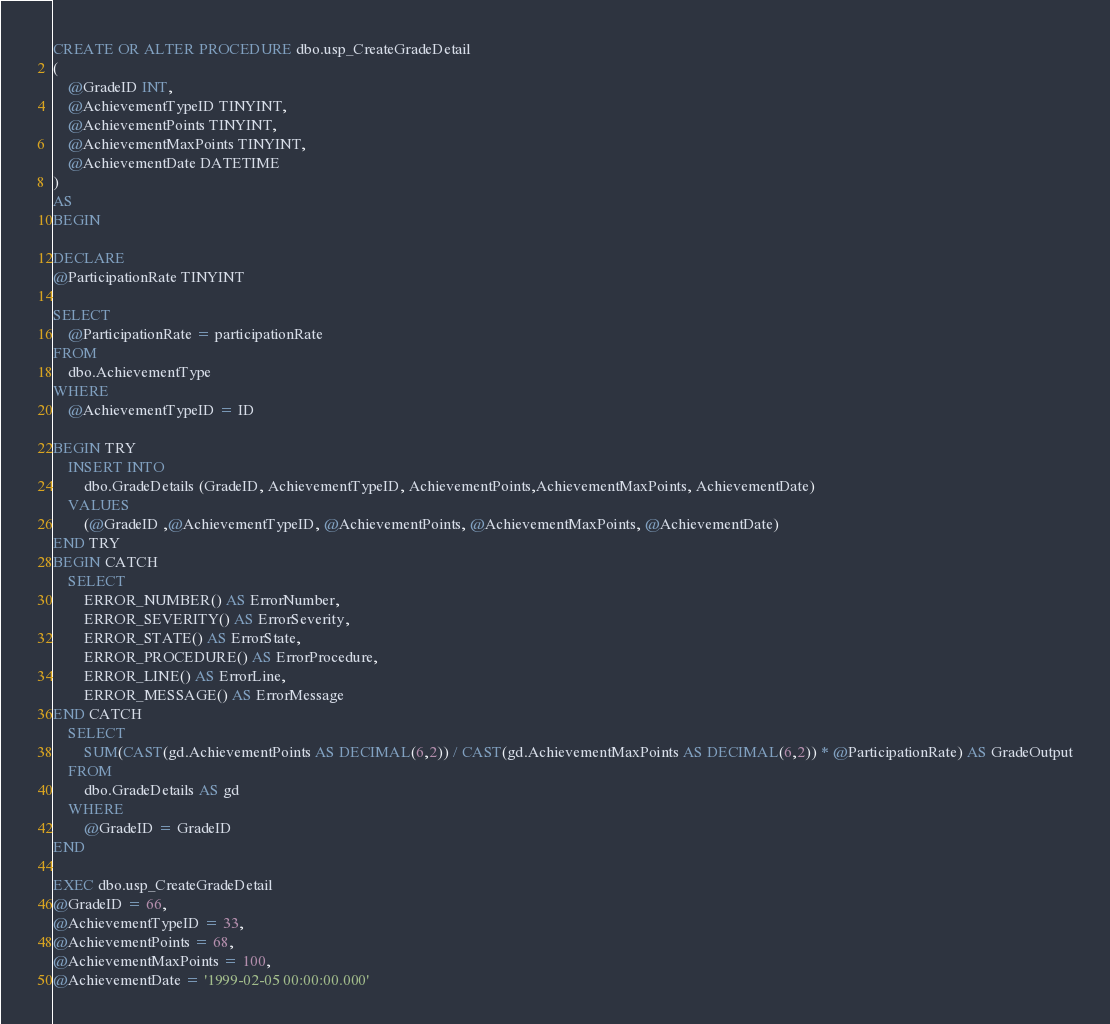Convert code to text. <code><loc_0><loc_0><loc_500><loc_500><_SQL_>CREATE OR ALTER PROCEDURE dbo.usp_CreateGradeDetail
(
	@GradeID INT,
	@AchievementTypeID TINYINT,
	@AchievementPoints TINYINT,
	@AchievementMaxPoints TINYINT,
	@AchievementDate DATETIME
)
AS
BEGIN

DECLARE 
@ParticipationRate TINYINT

SELECT 
	@ParticipationRate = participationRate
FROM 
	dbo.AchievementType
WHERE 
	@AchievementTypeID = ID

BEGIN TRY
	INSERT INTO 
		dbo.GradeDetails (GradeID, AchievementTypeID, AchievementPoints,AchievementMaxPoints, AchievementDate)
	VALUES
		(@GradeID ,@AchievementTypeID, @AchievementPoints, @AchievementMaxPoints, @AchievementDate)
END TRY
BEGIN CATCH
	SELECT
		ERROR_NUMBER() AS ErrorNumber,
		ERROR_SEVERITY() AS ErrorSeverity,
		ERROR_STATE() AS ErrorState,
		ERROR_PROCEDURE() AS ErrorProcedure,
		ERROR_LINE() AS ErrorLine,
		ERROR_MESSAGE() AS ErrorMessage
END CATCH
	SELECT 
		SUM(CAST(gd.AchievementPoints AS DECIMAL(6,2)) / CAST(gd.AchievementMaxPoints AS DECIMAL(6,2)) * @ParticipationRate) AS GradeOutput
	FROM 
		dbo.GradeDetails AS gd 
	WHERE
		@GradeID = GradeID
END

EXEC dbo.usp_CreateGradeDetail
@GradeID = 66,
@AchievementTypeID = 33,
@AchievementPoints = 68,
@AchievementMaxPoints = 100,
@AchievementDate = '1999-02-05 00:00:00.000'</code> 